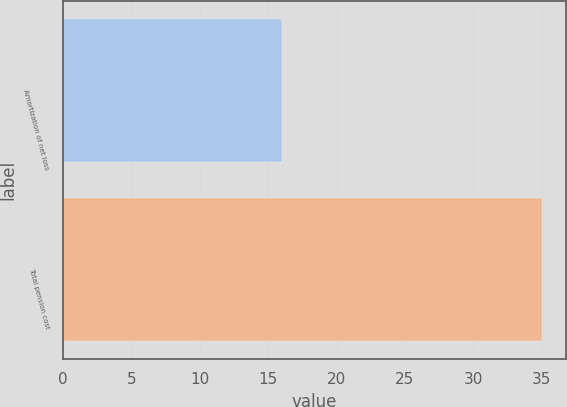Convert chart to OTSL. <chart><loc_0><loc_0><loc_500><loc_500><bar_chart><fcel>Amortization of net loss<fcel>Total pension cost<nl><fcel>16<fcel>35<nl></chart> 